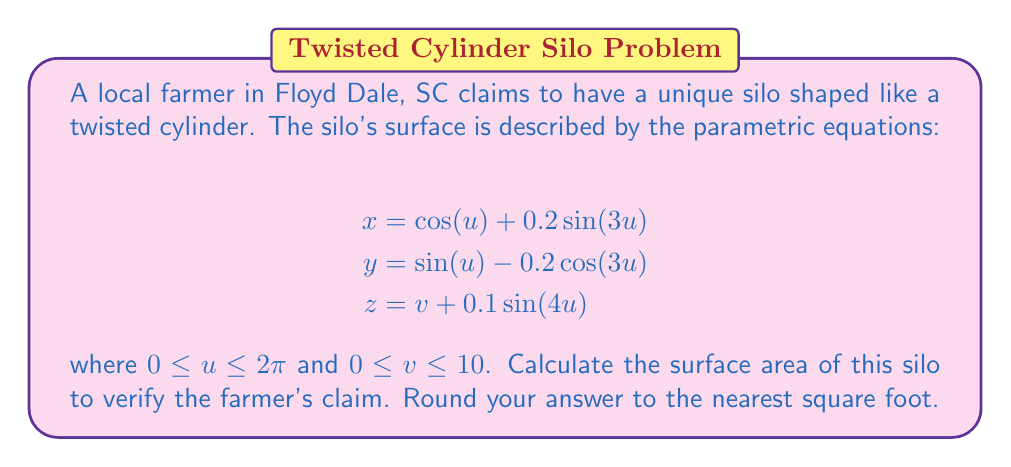Solve this math problem. To calculate the surface area of this parametric surface, we need to use the surface integral formula:

$$A = \int\int_S \sqrt{EG - F^2} \,du\,dv$$

where $E = x_u^2 + y_u^2 + z_u^2$, $F = x_u x_v + y_u y_v + z_u z_v$, and $G = x_v^2 + y_v^2 + z_v^2$.

Step 1: Calculate the partial derivatives
$$x_u = -\sin(u) + 0.6\cos(3u)$$
$$y_u = \cos(u) + 0.6\sin(3u)$$
$$z_u = 0.4\cos(4u)$$
$$x_v = 0$$
$$y_v = 0$$
$$z_v = 1$$

Step 2: Calculate E, F, and G
$$E = (-\sin(u) + 0.6\cos(3u))^2 + (\cos(u) + 0.6\sin(3u))^2 + (0.4\cos(4u))^2$$
$$F = 0$$
$$G = 1$$

Step 3: Simplify E
$$E = \sin^2(u) - 1.2\sin(u)\cos(3u) + 0.36\cos^2(3u) + \cos^2(u) + 1.2\cos(u)\sin(3u) + 0.36\sin^2(3u) + 0.16\cos^2(4u)$$
$$E = 1 + 0.36 + 0.16\cos^2(4u) = 1.36 + 0.16\cos^2(4u)$$

Step 4: Calculate the integrand
$$\sqrt{EG - F^2} = \sqrt{(1.36 + 0.16\cos^2(4u)) \cdot 1 - 0^2} = \sqrt{1.36 + 0.16\cos^2(4u)}$$

Step 5: Set up the double integral
$$A = \int_0^{10} \int_0^{2\pi} \sqrt{1.36 + 0.16\cos^2(4u)} \,du\,dv$$

Step 6: Evaluate the integral
The inner integral doesn't have an elementary antiderivative, so we need to use numerical integration. Using a computer algebra system or numerical integration tool, we get:

$$\int_0^{2\pi} \sqrt{1.36 + 0.16\cos^2(4u)} \,du \approx 7.3896$$

Now, we can evaluate the outer integral:

$$A = \int_0^{10} 7.3896 \,dv = 73.896$$

Step 7: Round to the nearest square foot
$$A \approx 74 \text{ sq ft}$$
Answer: 74 sq ft 